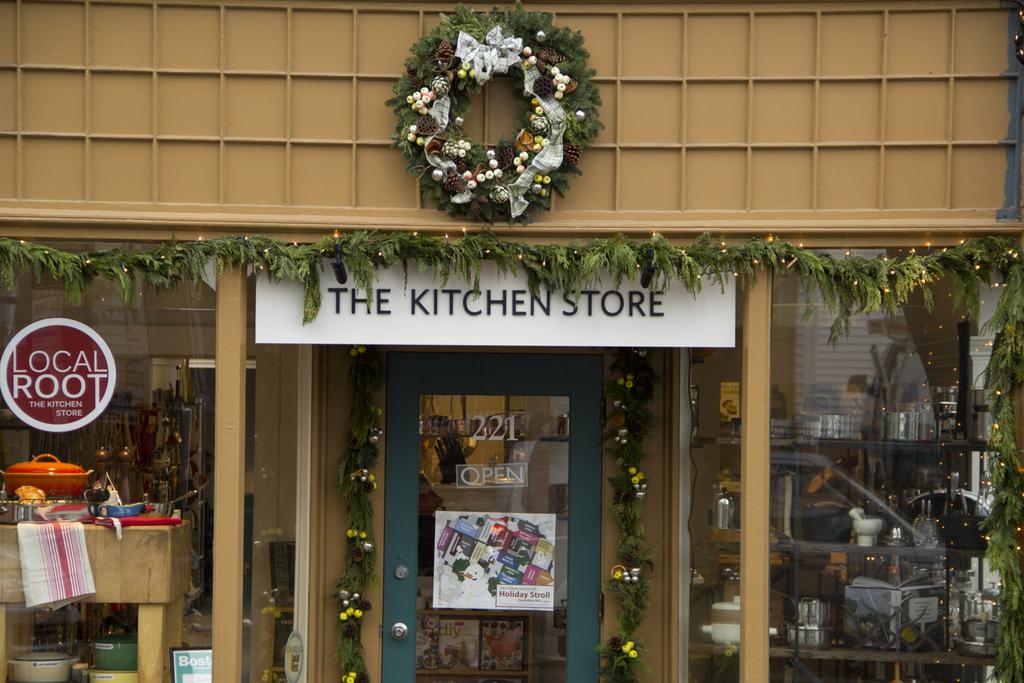What store is shown?
Provide a short and direct response. The kitchen store. What does it say in the round image on the window?
Provide a succinct answer. Local root. 